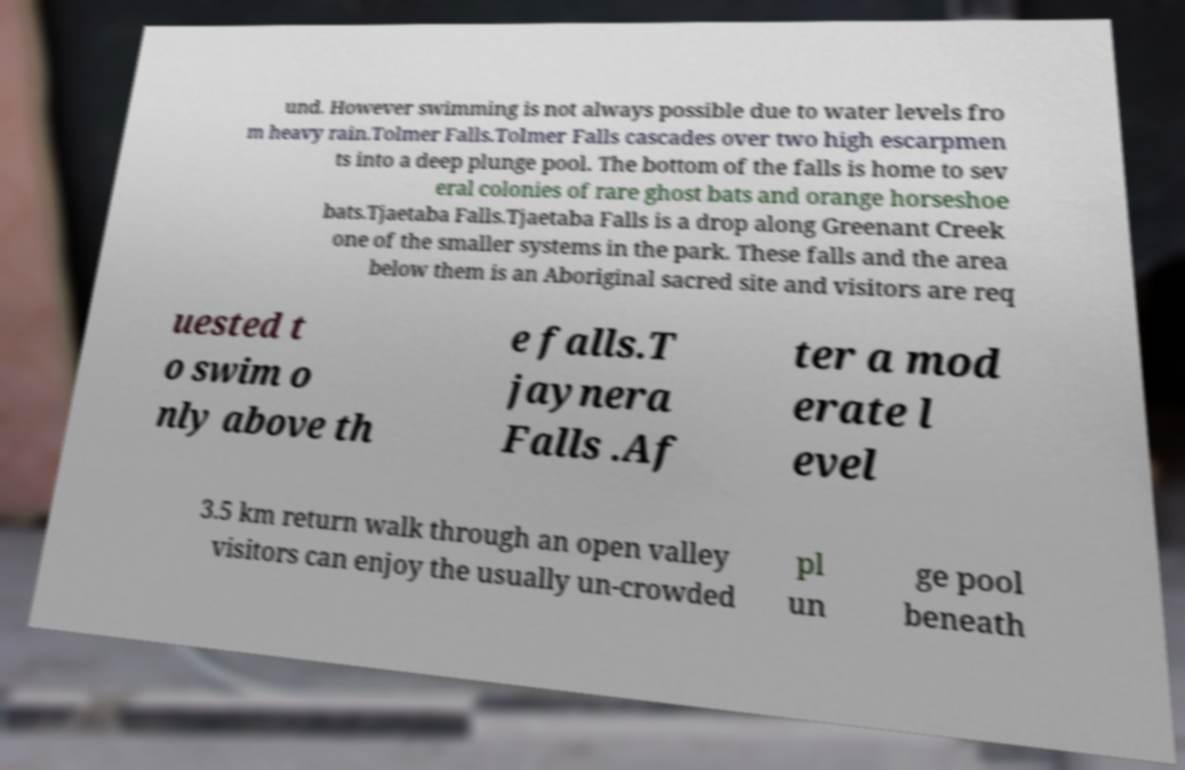Please identify and transcribe the text found in this image. und. However swimming is not always possible due to water levels fro m heavy rain.Tolmer Falls.Tolmer Falls cascades over two high escarpmen ts into a deep plunge pool. The bottom of the falls is home to sev eral colonies of rare ghost bats and orange horseshoe bats.Tjaetaba Falls.Tjaetaba Falls is a drop along Greenant Creek one of the smaller systems in the park. These falls and the area below them is an Aboriginal sacred site and visitors are req uested t o swim o nly above th e falls.T jaynera Falls .Af ter a mod erate l evel 3.5 km return walk through an open valley visitors can enjoy the usually un-crowded pl un ge pool beneath 